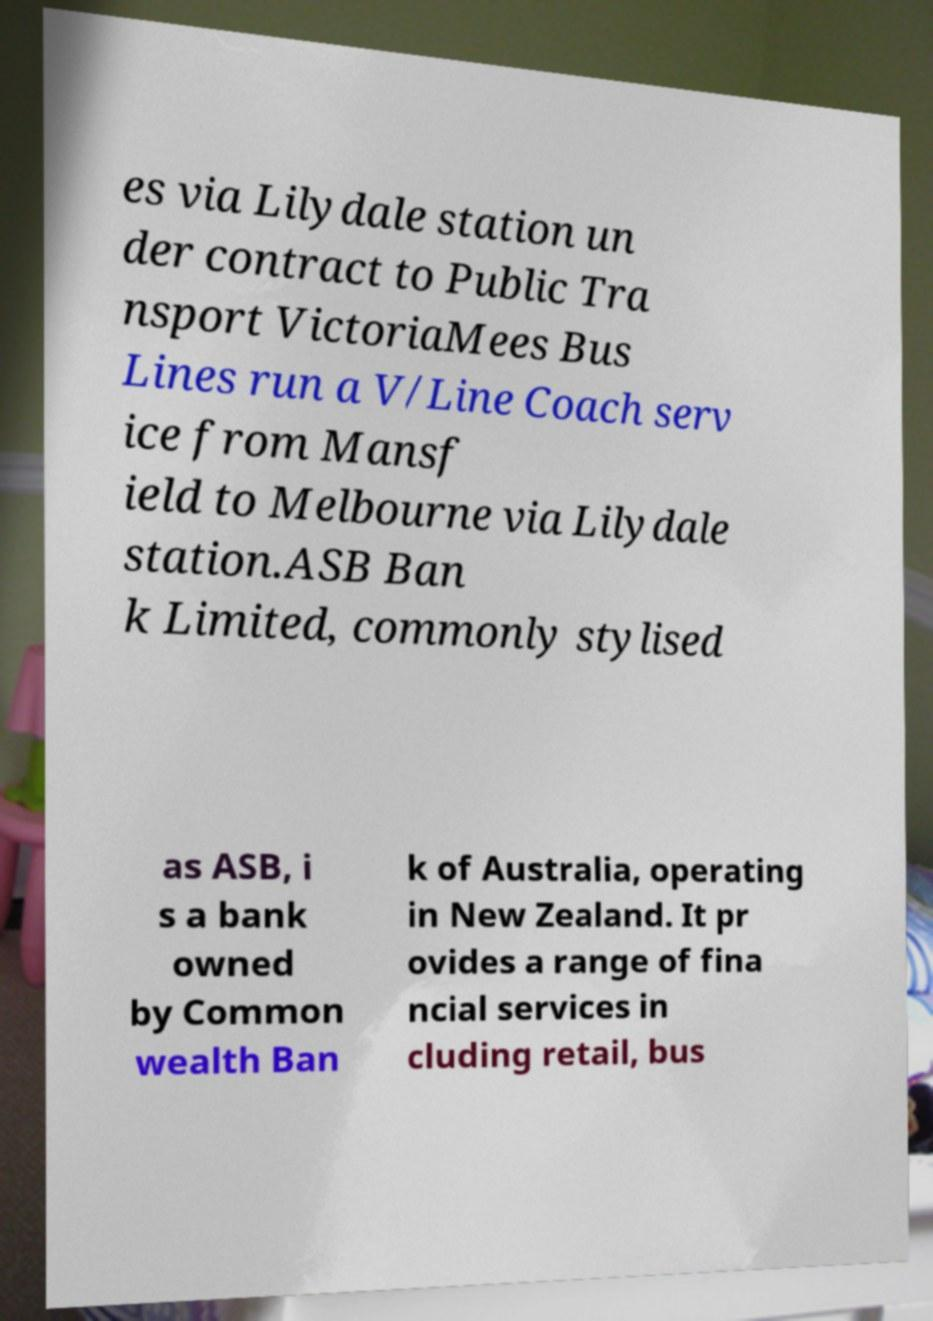Can you accurately transcribe the text from the provided image for me? es via Lilydale station un der contract to Public Tra nsport VictoriaMees Bus Lines run a V/Line Coach serv ice from Mansf ield to Melbourne via Lilydale station.ASB Ban k Limited, commonly stylised as ASB, i s a bank owned by Common wealth Ban k of Australia, operating in New Zealand. It pr ovides a range of fina ncial services in cluding retail, bus 